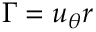Convert formula to latex. <formula><loc_0><loc_0><loc_500><loc_500>\Gamma = u _ { \theta } r</formula> 